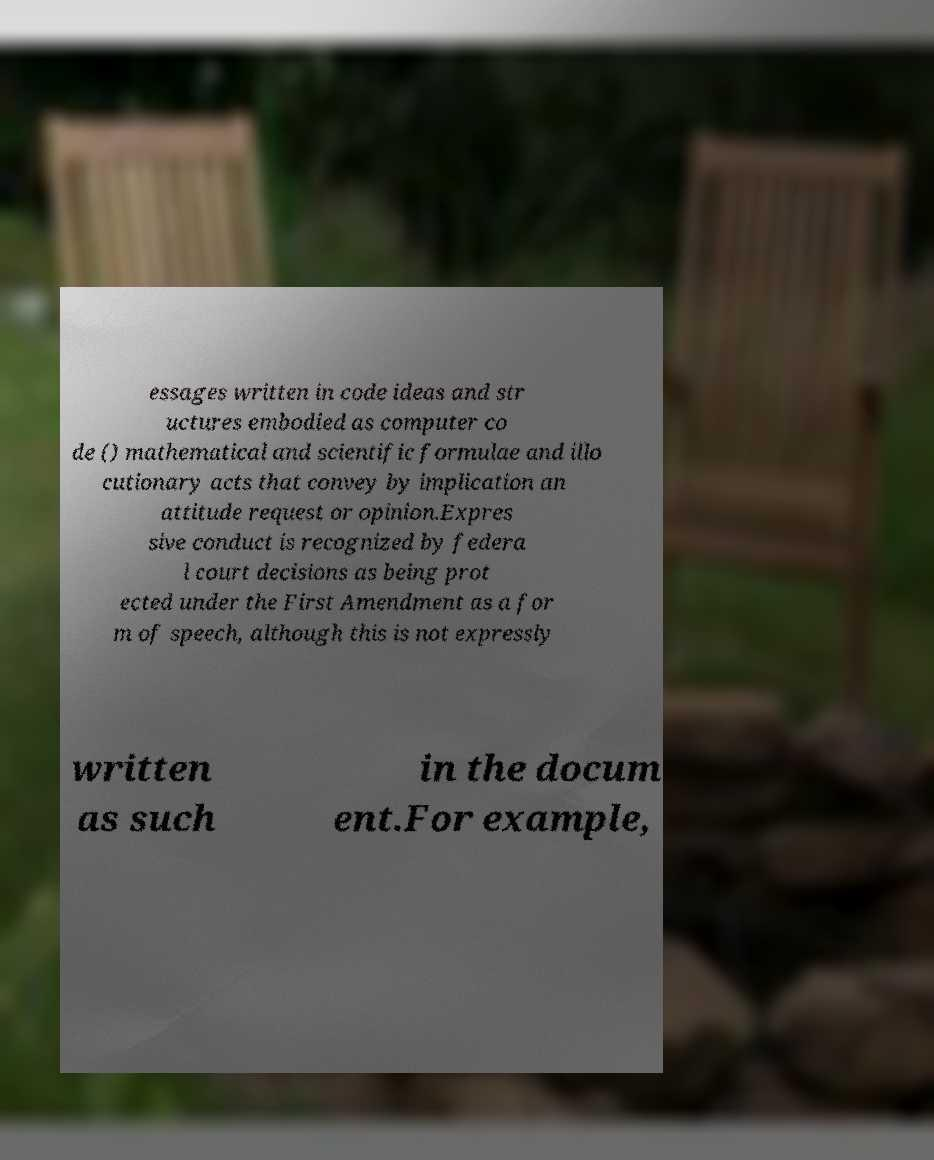For documentation purposes, I need the text within this image transcribed. Could you provide that? essages written in code ideas and str uctures embodied as computer co de () mathematical and scientific formulae and illo cutionary acts that convey by implication an attitude request or opinion.Expres sive conduct is recognized by federa l court decisions as being prot ected under the First Amendment as a for m of speech, although this is not expressly written as such in the docum ent.For example, 